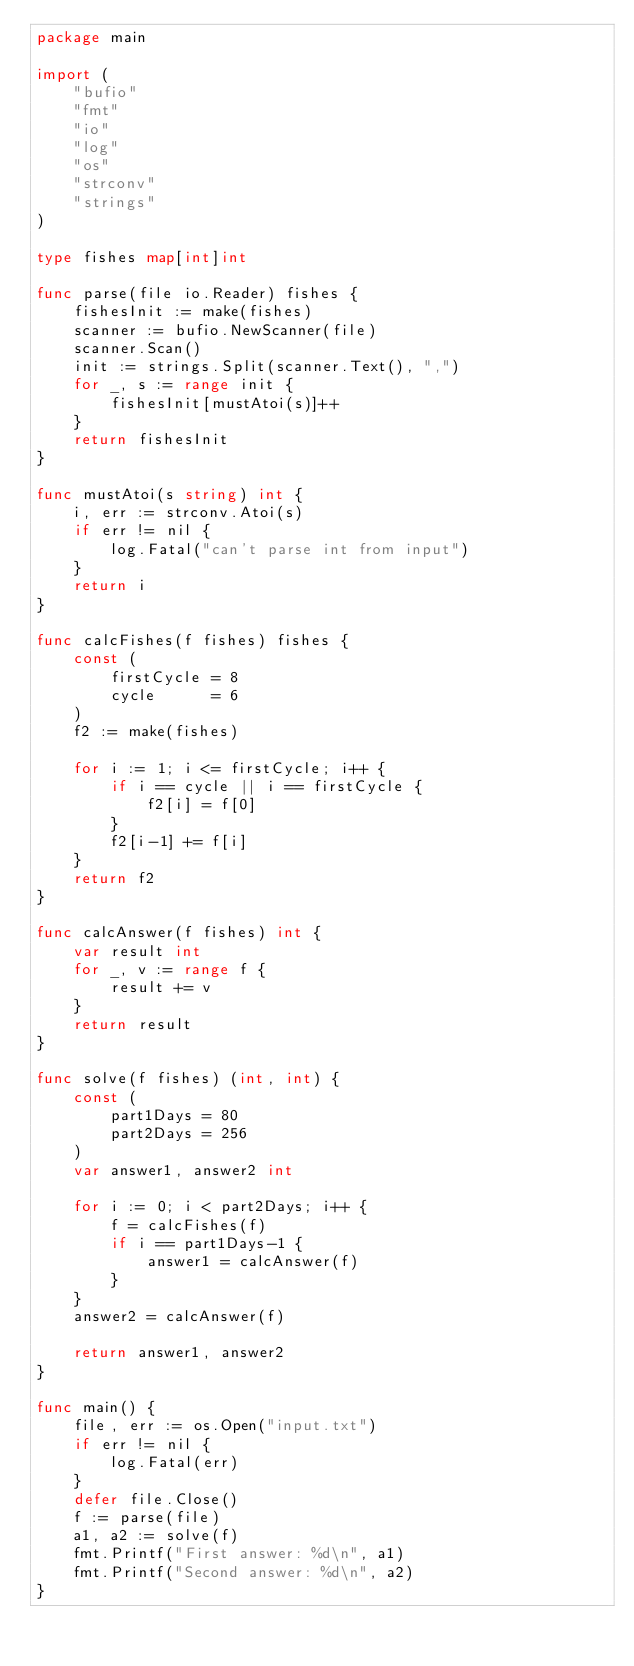Convert code to text. <code><loc_0><loc_0><loc_500><loc_500><_Go_>package main

import (
	"bufio"
	"fmt"
	"io"
	"log"
	"os"
	"strconv"
	"strings"
)

type fishes map[int]int

func parse(file io.Reader) fishes {
	fishesInit := make(fishes)
	scanner := bufio.NewScanner(file)
	scanner.Scan()
	init := strings.Split(scanner.Text(), ",")
	for _, s := range init {
		fishesInit[mustAtoi(s)]++
	}
	return fishesInit
}

func mustAtoi(s string) int {
	i, err := strconv.Atoi(s)
	if err != nil {
		log.Fatal("can't parse int from input")
	}
	return i
}

func calcFishes(f fishes) fishes {
	const (
		firstCycle = 8
		cycle      = 6
	)
	f2 := make(fishes)

	for i := 1; i <= firstCycle; i++ {
		if i == cycle || i == firstCycle {
			f2[i] = f[0]
		}
		f2[i-1] += f[i]
	}
	return f2
}

func calcAnswer(f fishes) int {
	var result int
	for _, v := range f {
		result += v
	}
	return result
}

func solve(f fishes) (int, int) {
	const (
		part1Days = 80
		part2Days = 256
	)
	var answer1, answer2 int

	for i := 0; i < part2Days; i++ {
		f = calcFishes(f)
		if i == part1Days-1 {
			answer1 = calcAnswer(f)
		}
	}
	answer2 = calcAnswer(f)

	return answer1, answer2
}

func main() {
	file, err := os.Open("input.txt")
	if err != nil {
		log.Fatal(err)
	}
	defer file.Close()
	f := parse(file)
	a1, a2 := solve(f)
	fmt.Printf("First answer: %d\n", a1)
	fmt.Printf("Second answer: %d\n", a2)
}
</code> 